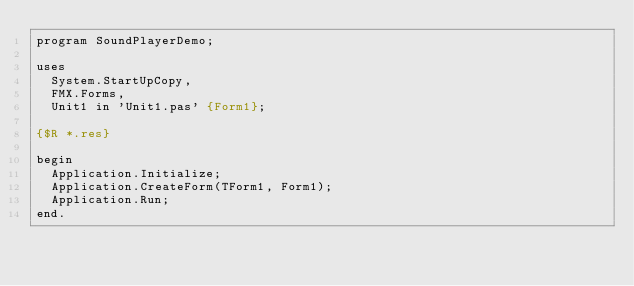<code> <loc_0><loc_0><loc_500><loc_500><_Pascal_>program SoundPlayerDemo;

uses
  System.StartUpCopy,
  FMX.Forms,
  Unit1 in 'Unit1.pas' {Form1};

{$R *.res}

begin
  Application.Initialize;
  Application.CreateForm(TForm1, Form1);
  Application.Run;
end.
</code> 